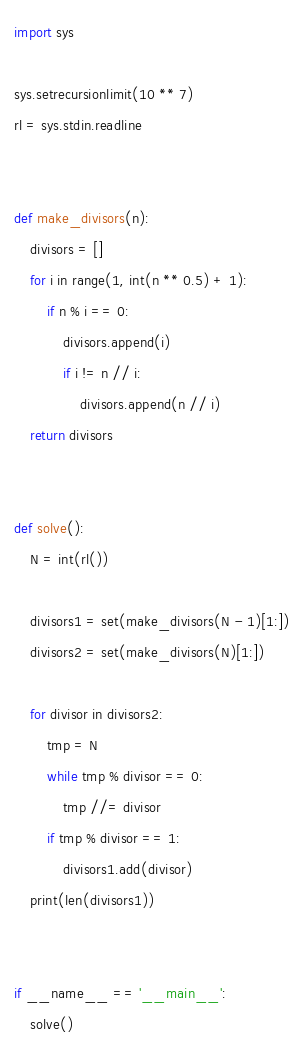Convert code to text. <code><loc_0><loc_0><loc_500><loc_500><_Python_>import sys

sys.setrecursionlimit(10 ** 7)
rl = sys.stdin.readline


def make_divisors(n):
    divisors = []
    for i in range(1, int(n ** 0.5) + 1):
        if n % i == 0:
            divisors.append(i)
            if i != n // i:
                divisors.append(n // i)
    return divisors


def solve():
    N = int(rl())
    
    divisors1 = set(make_divisors(N - 1)[1:])
    divisors2 = set(make_divisors(N)[1:])
    
    for divisor in divisors2:
        tmp = N
        while tmp % divisor == 0:
            tmp //= divisor
        if tmp % divisor == 1:
            divisors1.add(divisor)
    print(len(divisors1))


if __name__ == '__main__':
    solve()
</code> 